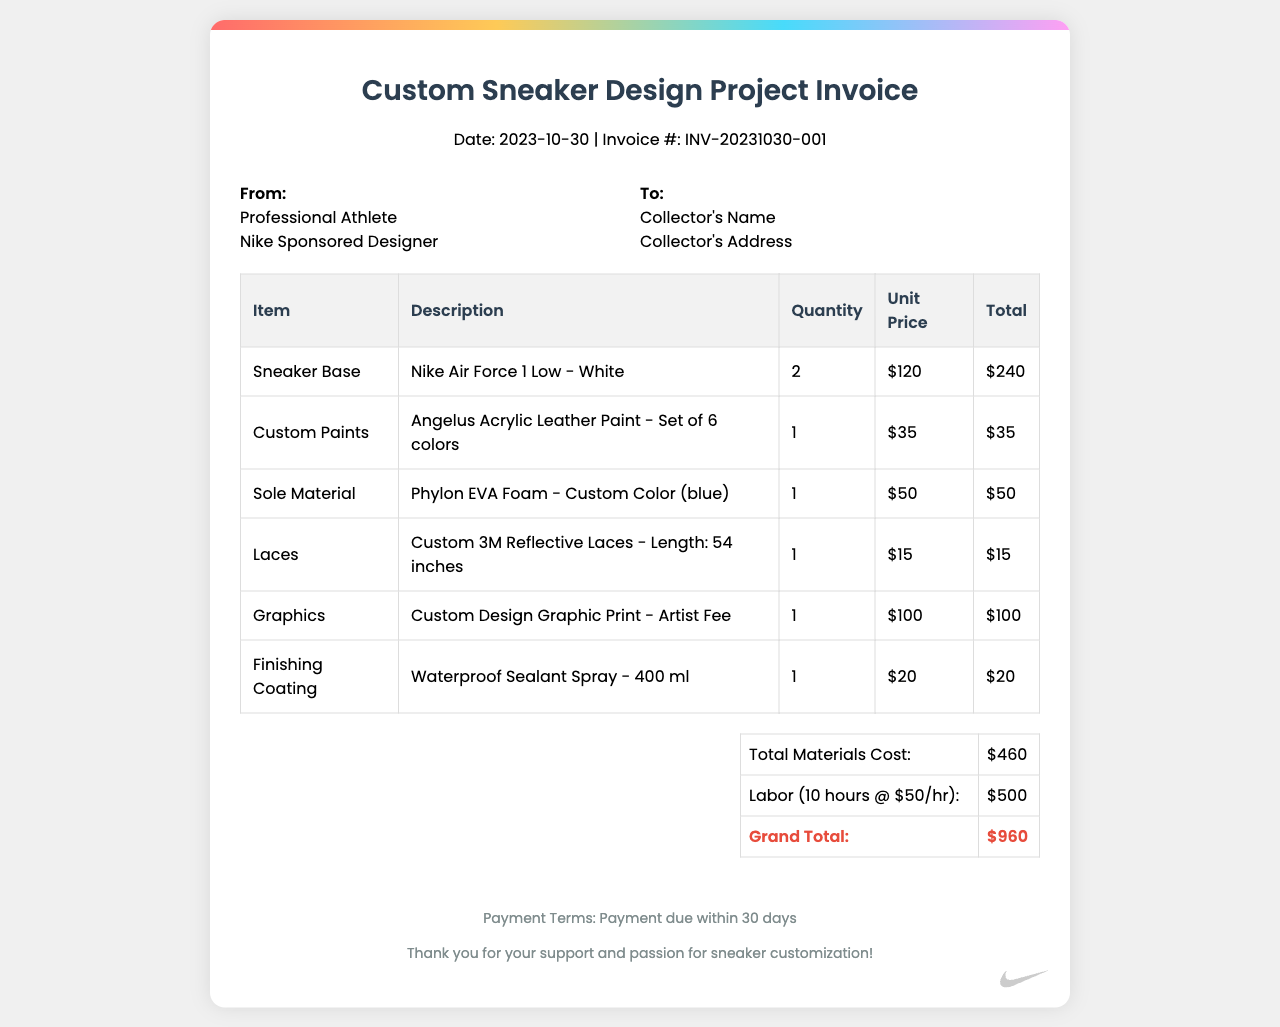What is the invoice date? The invoice date is explicitly mentioned in the document header.
Answer: 2023-10-30 What is the invoice number? The invoice number is provided in the document header as a unique identification for the invoice.
Answer: INV-20231030-001 What is the quantity of sneaker bases? The quantity of sneaker bases is listed in the table under the "Quantity" column for the sneaker base item.
Answer: 2 What is the total cost of materials? The total materials cost is summarized at the bottom of the invoice, reflecting the expenses for all materials used.
Answer: $460 How much was charged for labor? The total labor cost is presented in the summary table, indicating the hours worked and the rate per hour.
Answer: $500 What type of sneakers is being designed? The type of sneakers can be found in the description of the sneaker base item listed in the table.
Answer: Nike Air Force 1 Low - White What is the grand total of the invoice? The grand total is the final amount due, calculated by summing materials cost and labor charges.
Answer: $960 What is the rate per hour for labor? The rate is specified in the labor description within the summary, detailing how the total labor cost was calculated.
Answer: $50 What is the payment term stated in the document? The payment term is explicitly indicated in the footer, outlining when the payment is due.
Answer: Payment due within 30 days 